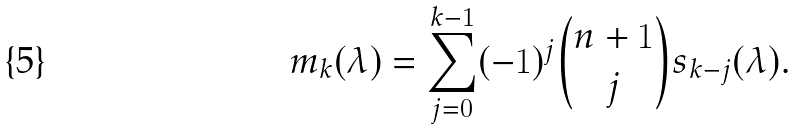Convert formula to latex. <formula><loc_0><loc_0><loc_500><loc_500>m _ { k } ( \lambda ) = \sum _ { j = 0 } ^ { k - 1 } ( - 1 ) ^ { j } { { n + 1 } \choose { j } } s _ { k - j } ( \lambda ) .</formula> 